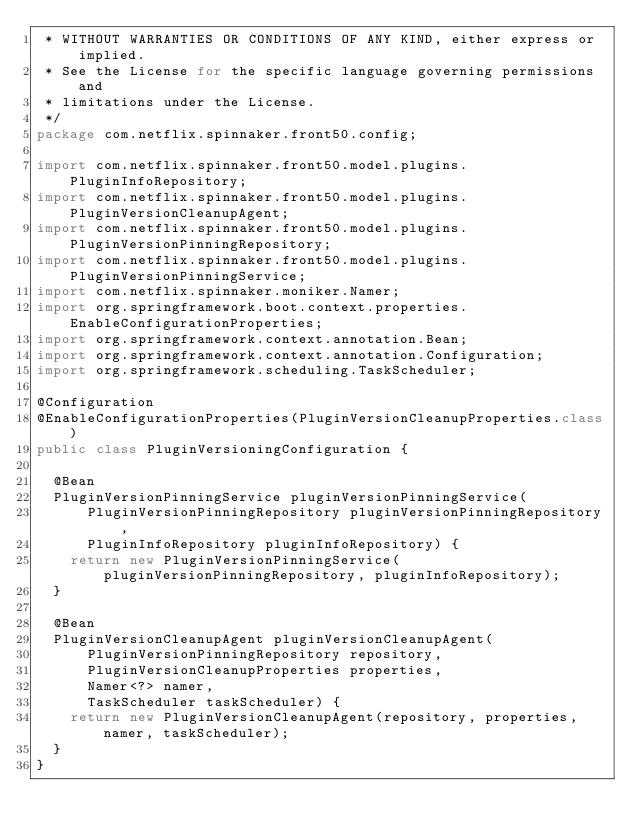<code> <loc_0><loc_0><loc_500><loc_500><_Java_> * WITHOUT WARRANTIES OR CONDITIONS OF ANY KIND, either express or implied.
 * See the License for the specific language governing permissions and
 * limitations under the License.
 */
package com.netflix.spinnaker.front50.config;

import com.netflix.spinnaker.front50.model.plugins.PluginInfoRepository;
import com.netflix.spinnaker.front50.model.plugins.PluginVersionCleanupAgent;
import com.netflix.spinnaker.front50.model.plugins.PluginVersionPinningRepository;
import com.netflix.spinnaker.front50.model.plugins.PluginVersionPinningService;
import com.netflix.spinnaker.moniker.Namer;
import org.springframework.boot.context.properties.EnableConfigurationProperties;
import org.springframework.context.annotation.Bean;
import org.springframework.context.annotation.Configuration;
import org.springframework.scheduling.TaskScheduler;

@Configuration
@EnableConfigurationProperties(PluginVersionCleanupProperties.class)
public class PluginVersioningConfiguration {

  @Bean
  PluginVersionPinningService pluginVersionPinningService(
      PluginVersionPinningRepository pluginVersionPinningRepository,
      PluginInfoRepository pluginInfoRepository) {
    return new PluginVersionPinningService(pluginVersionPinningRepository, pluginInfoRepository);
  }

  @Bean
  PluginVersionCleanupAgent pluginVersionCleanupAgent(
      PluginVersionPinningRepository repository,
      PluginVersionCleanupProperties properties,
      Namer<?> namer,
      TaskScheduler taskScheduler) {
    return new PluginVersionCleanupAgent(repository, properties, namer, taskScheduler);
  }
}
</code> 